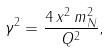Convert formula to latex. <formula><loc_0><loc_0><loc_500><loc_500>\gamma ^ { 2 } = \frac { 4 \, x ^ { 2 } \, m _ { N } ^ { 2 } } { Q ^ { 2 } } ,</formula> 